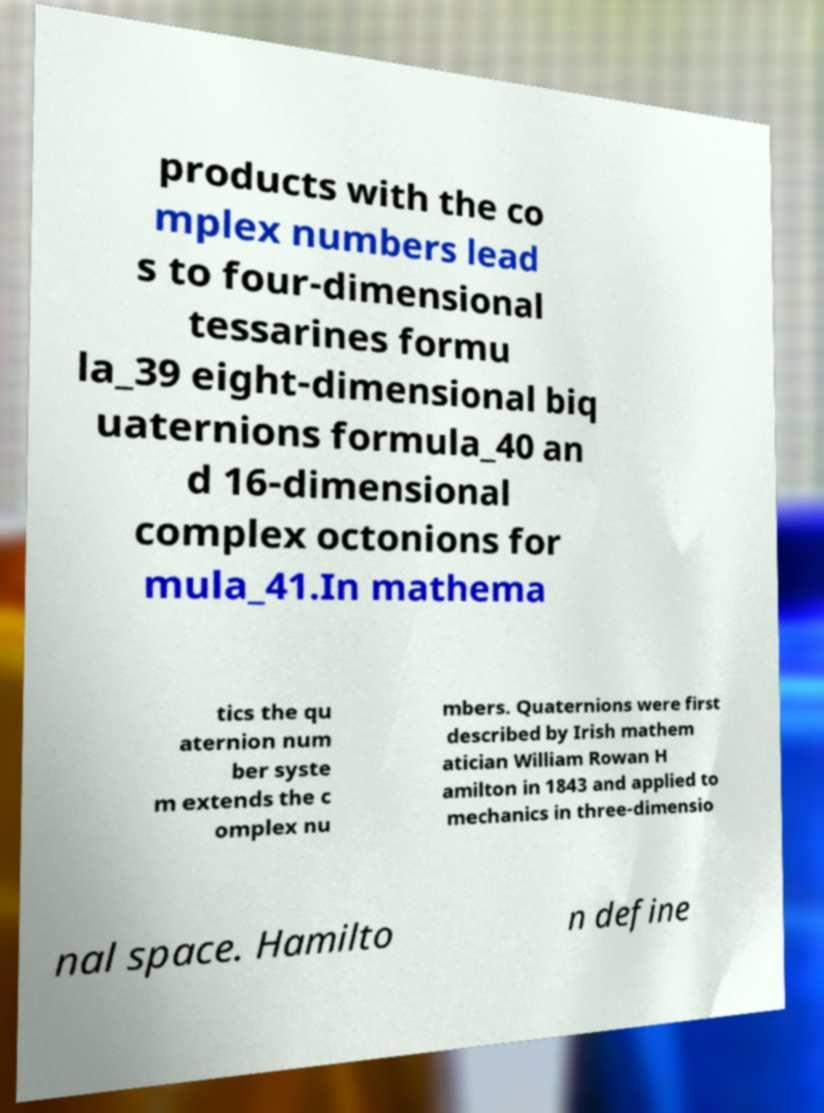Can you accurately transcribe the text from the provided image for me? products with the co mplex numbers lead s to four-dimensional tessarines formu la_39 eight-dimensional biq uaternions formula_40 an d 16-dimensional complex octonions for mula_41.In mathema tics the qu aternion num ber syste m extends the c omplex nu mbers. Quaternions were first described by Irish mathem atician William Rowan H amilton in 1843 and applied to mechanics in three-dimensio nal space. Hamilto n define 